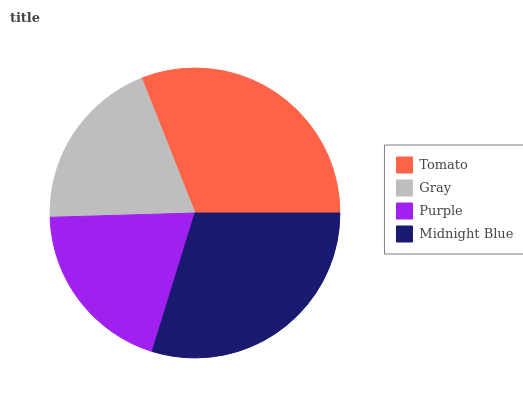Is Gray the minimum?
Answer yes or no. Yes. Is Tomato the maximum?
Answer yes or no. Yes. Is Purple the minimum?
Answer yes or no. No. Is Purple the maximum?
Answer yes or no. No. Is Purple greater than Gray?
Answer yes or no. Yes. Is Gray less than Purple?
Answer yes or no. Yes. Is Gray greater than Purple?
Answer yes or no. No. Is Purple less than Gray?
Answer yes or no. No. Is Midnight Blue the high median?
Answer yes or no. Yes. Is Purple the low median?
Answer yes or no. Yes. Is Gray the high median?
Answer yes or no. No. Is Tomato the low median?
Answer yes or no. No. 